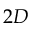<formula> <loc_0><loc_0><loc_500><loc_500>2 D</formula> 